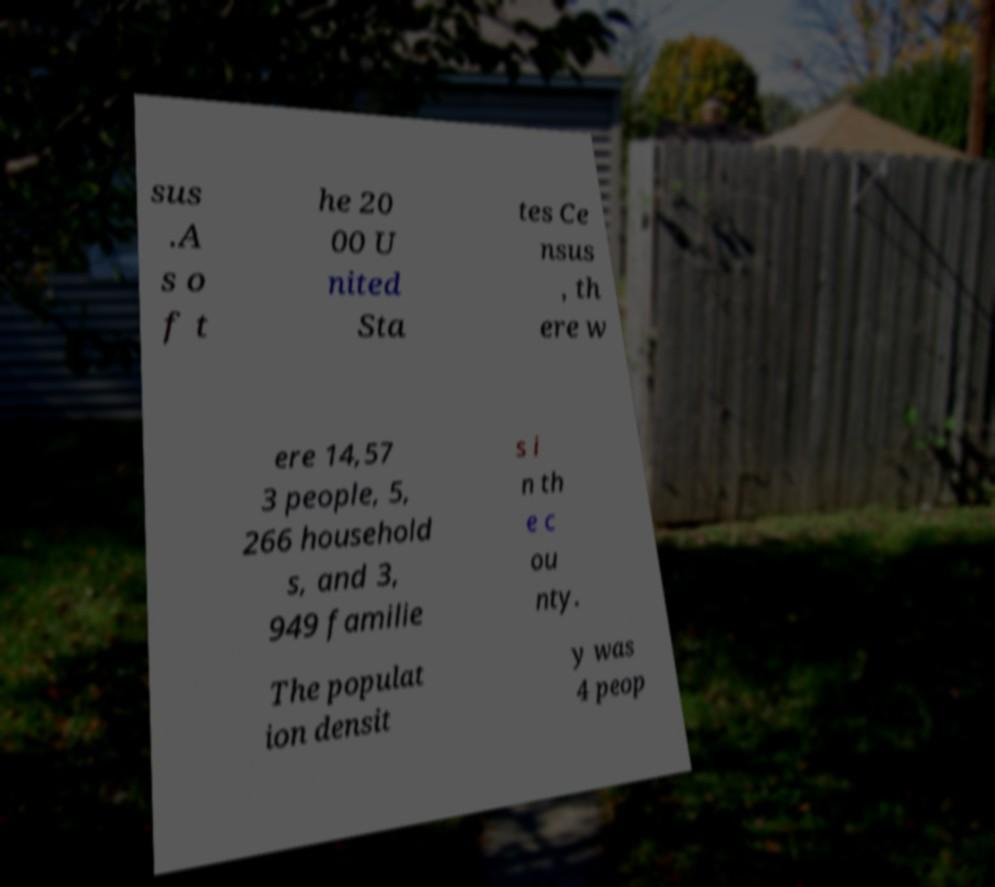Can you read and provide the text displayed in the image?This photo seems to have some interesting text. Can you extract and type it out for me? sus .A s o f t he 20 00 U nited Sta tes Ce nsus , th ere w ere 14,57 3 people, 5, 266 household s, and 3, 949 familie s i n th e c ou nty. The populat ion densit y was 4 peop 